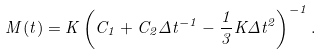<formula> <loc_0><loc_0><loc_500><loc_500>M ( t ) = K \left ( C _ { 1 } + C _ { 2 } \Delta t ^ { - 1 } - \frac { 1 } { 3 } K \Delta t ^ { 2 } \right ) ^ { - 1 } .</formula> 